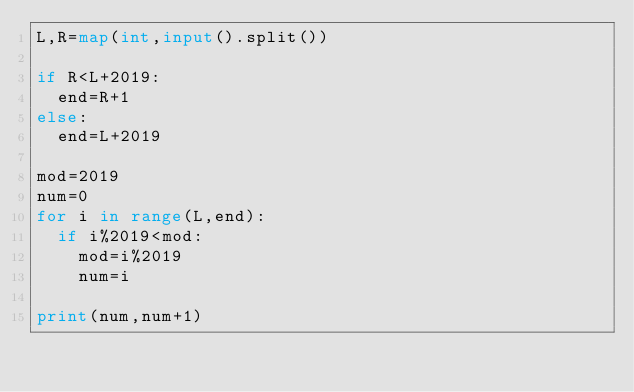Convert code to text. <code><loc_0><loc_0><loc_500><loc_500><_Python_>L,R=map(int,input().split())

if R<L+2019:
  end=R+1
else:
  end=L+2019

mod=2019
num=0
for i in range(L,end):
  if i%2019<mod:
    mod=i%2019
    num=i

print(num,num+1)</code> 